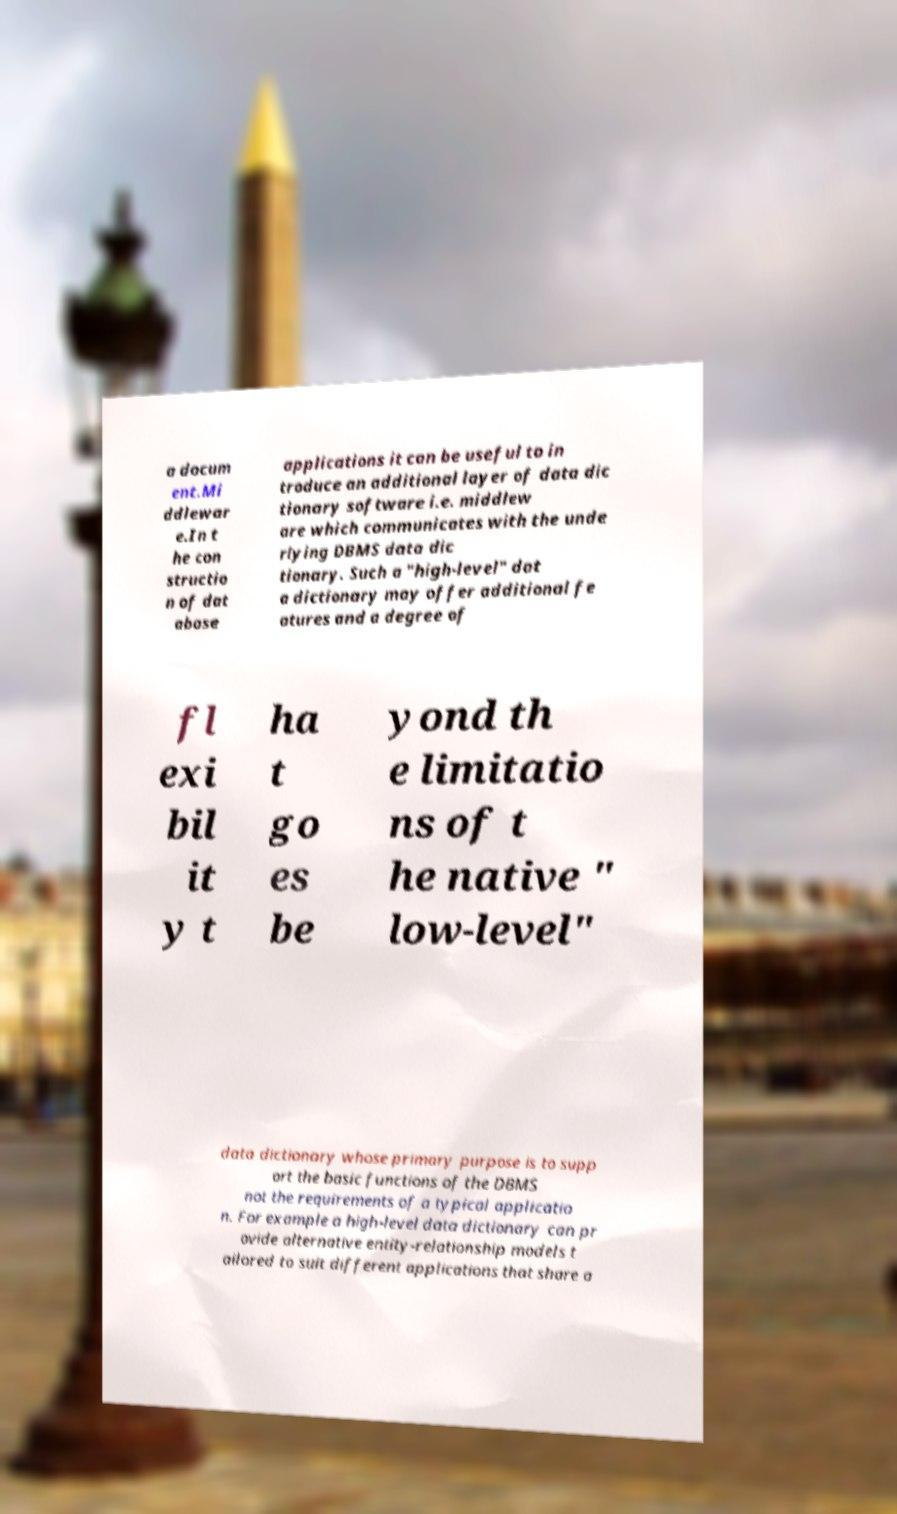Can you read and provide the text displayed in the image?This photo seems to have some interesting text. Can you extract and type it out for me? a docum ent.Mi ddlewar e.In t he con structio n of dat abase applications it can be useful to in troduce an additional layer of data dic tionary software i.e. middlew are which communicates with the unde rlying DBMS data dic tionary. Such a "high-level" dat a dictionary may offer additional fe atures and a degree of fl exi bil it y t ha t go es be yond th e limitatio ns of t he native " low-level" data dictionary whose primary purpose is to supp ort the basic functions of the DBMS not the requirements of a typical applicatio n. For example a high-level data dictionary can pr ovide alternative entity-relationship models t ailored to suit different applications that share a 